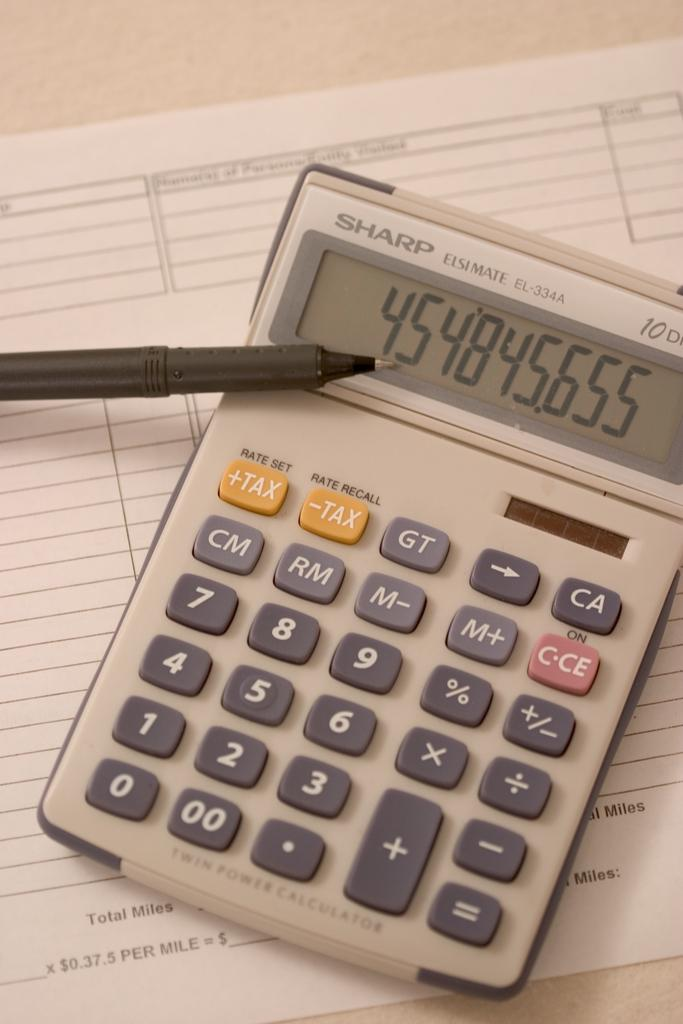What device is present in the picture? There is a calculator in the picture. Is there anything placed on top of the calculator? Yes, there is a pen placed on the calculator. What is located beneath the calculator? There is a paper below the calculator. What type of verse can be seen framed on the wall in the image? There is no frame or verse present in the image; it only features a calculator, a pen, and a paper. 